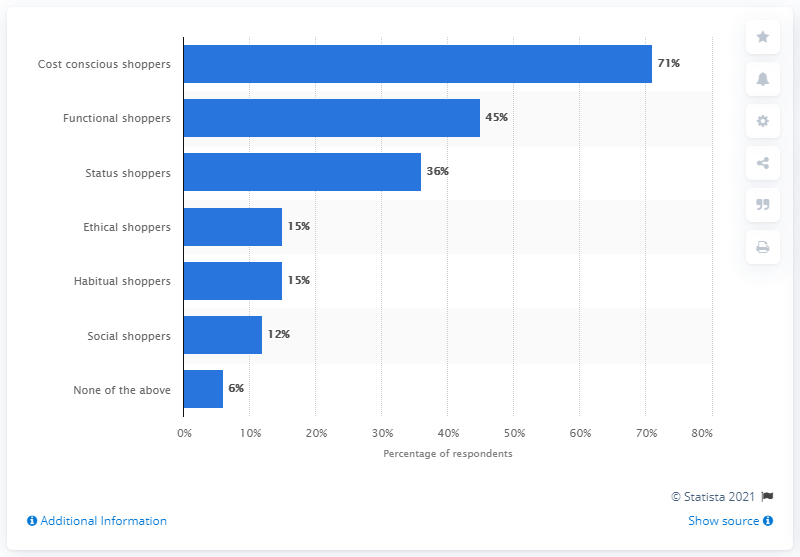Point out several critical features in this image. A survey revealed that 15% of shoppers were classified as ethical and habitual, meaning they prioritize ethical and sustainable shopping practices and consistently engage in them. 